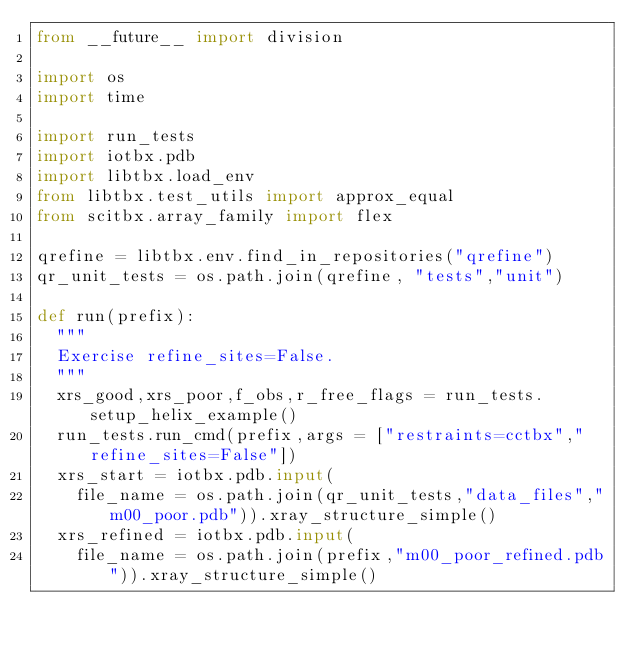<code> <loc_0><loc_0><loc_500><loc_500><_Python_>from __future__ import division

import os
import time

import run_tests
import iotbx.pdb
import libtbx.load_env
from libtbx.test_utils import approx_equal
from scitbx.array_family import flex

qrefine = libtbx.env.find_in_repositories("qrefine")
qr_unit_tests = os.path.join(qrefine, "tests","unit")

def run(prefix):
  """
  Exercise refine_sites=False.
  """
  xrs_good,xrs_poor,f_obs,r_free_flags = run_tests.setup_helix_example()
  run_tests.run_cmd(prefix,args = ["restraints=cctbx","refine_sites=False"])
  xrs_start = iotbx.pdb.input(
    file_name = os.path.join(qr_unit_tests,"data_files","m00_poor.pdb")).xray_structure_simple()
  xrs_refined = iotbx.pdb.input(
    file_name = os.path.join(prefix,"m00_poor_refined.pdb")).xray_structure_simple()</code> 